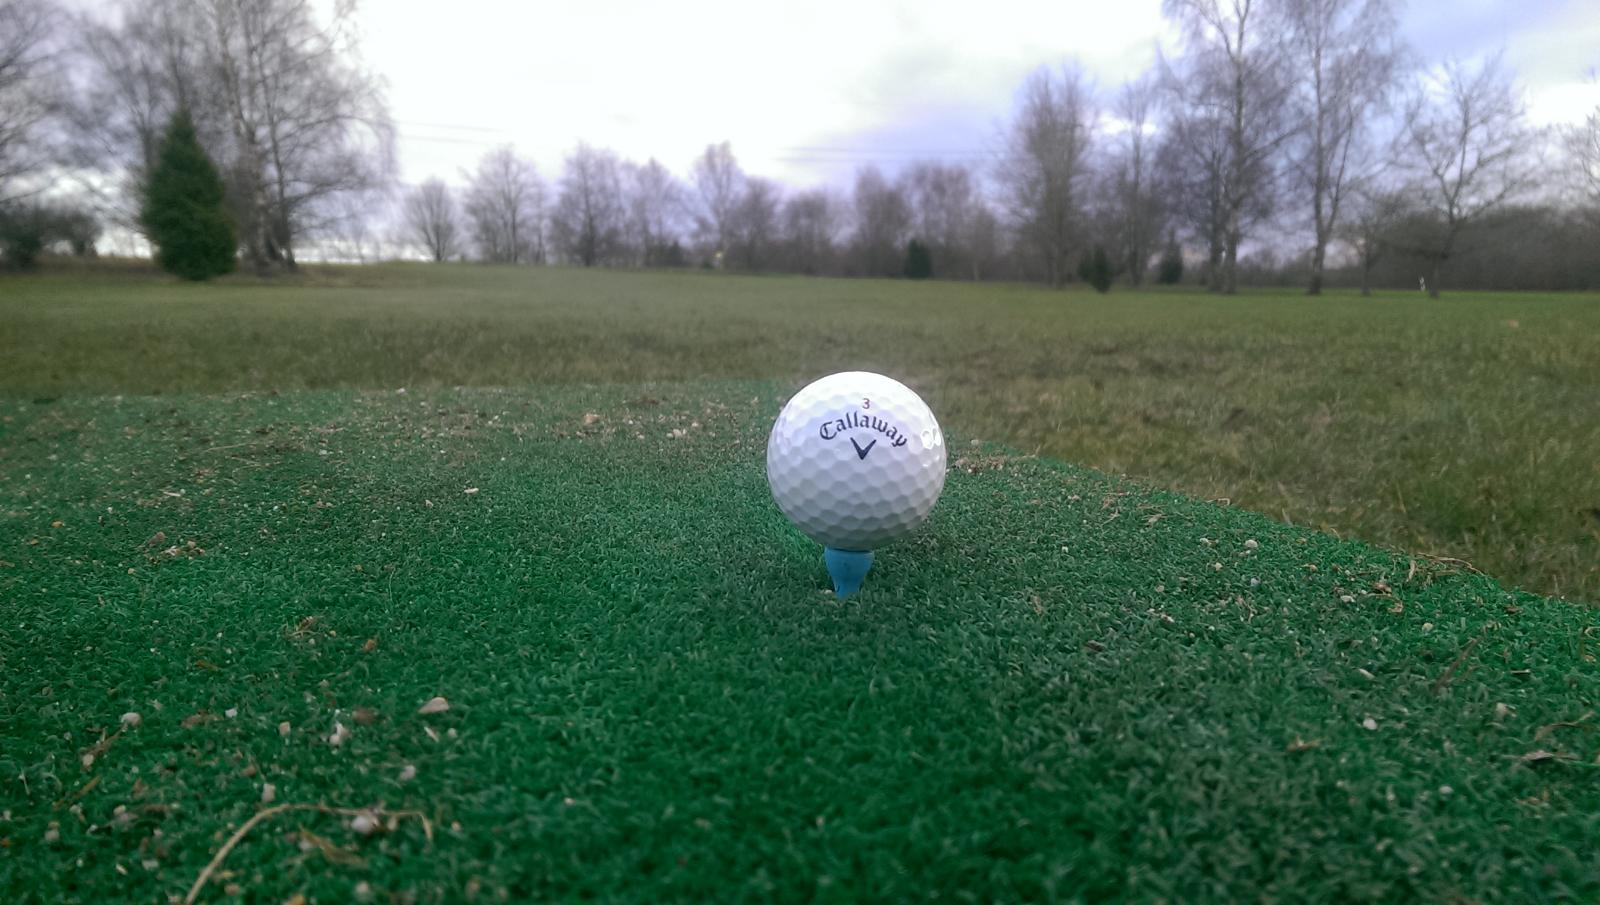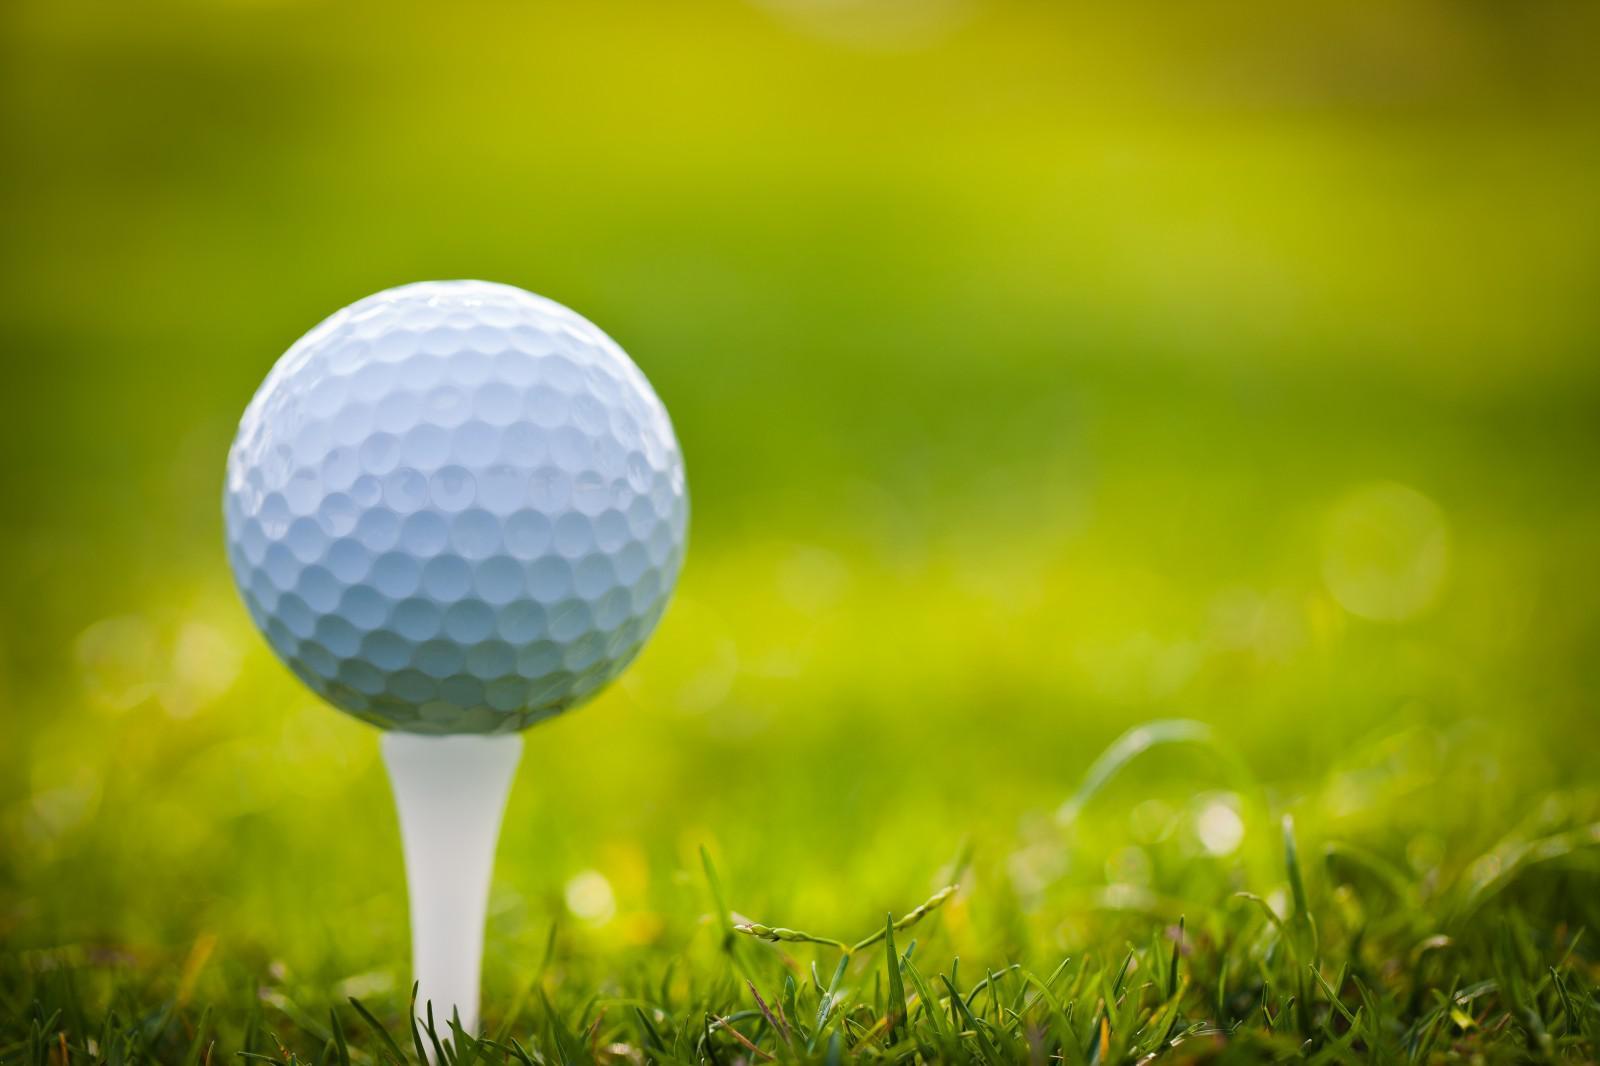The first image is the image on the left, the second image is the image on the right. Analyze the images presented: Is the assertion "All golf balls are sitting on tees in grassy areas." valid? Answer yes or no. Yes. 